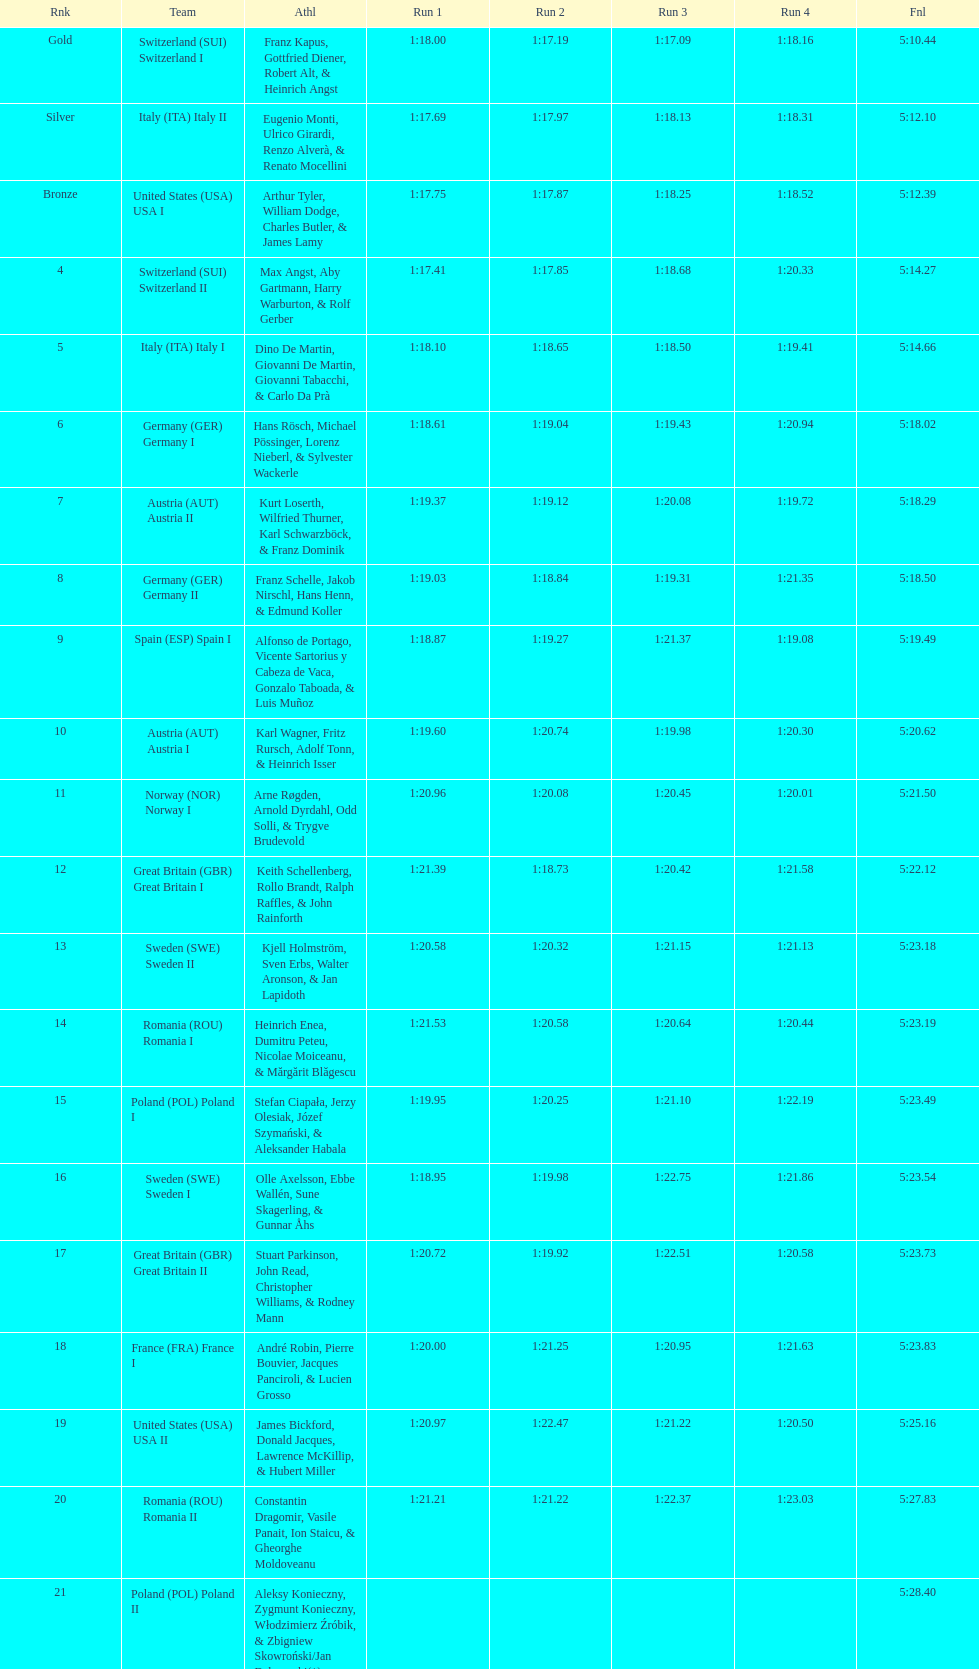What team came in second to last place? Romania. Could you parse the entire table as a dict? {'header': ['Rnk', 'Team', 'Athl', 'Run 1', 'Run 2', 'Run 3', 'Run 4', 'Fnl'], 'rows': [['Gold', 'Switzerland\xa0(SUI) Switzerland I', 'Franz Kapus, Gottfried Diener, Robert Alt, & Heinrich Angst', '1:18.00', '1:17.19', '1:17.09', '1:18.16', '5:10.44'], ['Silver', 'Italy\xa0(ITA) Italy II', 'Eugenio Monti, Ulrico Girardi, Renzo Alverà, & Renato Mocellini', '1:17.69', '1:17.97', '1:18.13', '1:18.31', '5:12.10'], ['Bronze', 'United States\xa0(USA) USA I', 'Arthur Tyler, William Dodge, Charles Butler, & James Lamy', '1:17.75', '1:17.87', '1:18.25', '1:18.52', '5:12.39'], ['4', 'Switzerland\xa0(SUI) Switzerland II', 'Max Angst, Aby Gartmann, Harry Warburton, & Rolf Gerber', '1:17.41', '1:17.85', '1:18.68', '1:20.33', '5:14.27'], ['5', 'Italy\xa0(ITA) Italy I', 'Dino De Martin, Giovanni De Martin, Giovanni Tabacchi, & Carlo Da Prà', '1:18.10', '1:18.65', '1:18.50', '1:19.41', '5:14.66'], ['6', 'Germany\xa0(GER) Germany I', 'Hans Rösch, Michael Pössinger, Lorenz Nieberl, & Sylvester Wackerle', '1:18.61', '1:19.04', '1:19.43', '1:20.94', '5:18.02'], ['7', 'Austria\xa0(AUT) Austria II', 'Kurt Loserth, Wilfried Thurner, Karl Schwarzböck, & Franz Dominik', '1:19.37', '1:19.12', '1:20.08', '1:19.72', '5:18.29'], ['8', 'Germany\xa0(GER) Germany II', 'Franz Schelle, Jakob Nirschl, Hans Henn, & Edmund Koller', '1:19.03', '1:18.84', '1:19.31', '1:21.35', '5:18.50'], ['9', 'Spain\xa0(ESP) Spain I', 'Alfonso de Portago, Vicente Sartorius y Cabeza de Vaca, Gonzalo Taboada, & Luis Muñoz', '1:18.87', '1:19.27', '1:21.37', '1:19.08', '5:19.49'], ['10', 'Austria\xa0(AUT) Austria I', 'Karl Wagner, Fritz Rursch, Adolf Tonn, & Heinrich Isser', '1:19.60', '1:20.74', '1:19.98', '1:20.30', '5:20.62'], ['11', 'Norway\xa0(NOR) Norway I', 'Arne Røgden, Arnold Dyrdahl, Odd Solli, & Trygve Brudevold', '1:20.96', '1:20.08', '1:20.45', '1:20.01', '5:21.50'], ['12', 'Great Britain\xa0(GBR) Great Britain I', 'Keith Schellenberg, Rollo Brandt, Ralph Raffles, & John Rainforth', '1:21.39', '1:18.73', '1:20.42', '1:21.58', '5:22.12'], ['13', 'Sweden\xa0(SWE) Sweden II', 'Kjell Holmström, Sven Erbs, Walter Aronson, & Jan Lapidoth', '1:20.58', '1:20.32', '1:21.15', '1:21.13', '5:23.18'], ['14', 'Romania\xa0(ROU) Romania I', 'Heinrich Enea, Dumitru Peteu, Nicolae Moiceanu, & Mărgărit Blăgescu', '1:21.53', '1:20.58', '1:20.64', '1:20.44', '5:23.19'], ['15', 'Poland\xa0(POL) Poland I', 'Stefan Ciapała, Jerzy Olesiak, Józef Szymański, & Aleksander Habala', '1:19.95', '1:20.25', '1:21.10', '1:22.19', '5:23.49'], ['16', 'Sweden\xa0(SWE) Sweden I', 'Olle Axelsson, Ebbe Wallén, Sune Skagerling, & Gunnar Åhs', '1:18.95', '1:19.98', '1:22.75', '1:21.86', '5:23.54'], ['17', 'Great Britain\xa0(GBR) Great Britain II', 'Stuart Parkinson, John Read, Christopher Williams, & Rodney Mann', '1:20.72', '1:19.92', '1:22.51', '1:20.58', '5:23.73'], ['18', 'France\xa0(FRA) France I', 'André Robin, Pierre Bouvier, Jacques Panciroli, & Lucien Grosso', '1:20.00', '1:21.25', '1:20.95', '1:21.63', '5:23.83'], ['19', 'United States\xa0(USA) USA II', 'James Bickford, Donald Jacques, Lawrence McKillip, & Hubert Miller', '1:20.97', '1:22.47', '1:21.22', '1:20.50', '5:25.16'], ['20', 'Romania\xa0(ROU) Romania II', 'Constantin Dragomir, Vasile Panait, Ion Staicu, & Gheorghe Moldoveanu', '1:21.21', '1:21.22', '1:22.37', '1:23.03', '5:27.83'], ['21', 'Poland\xa0(POL) Poland II', 'Aleksy Konieczny, Zygmunt Konieczny, Włodzimierz Źróbik, & Zbigniew Skowroński/Jan Dąbrowski(*)', '', '', '', '', '5:28.40']]} 